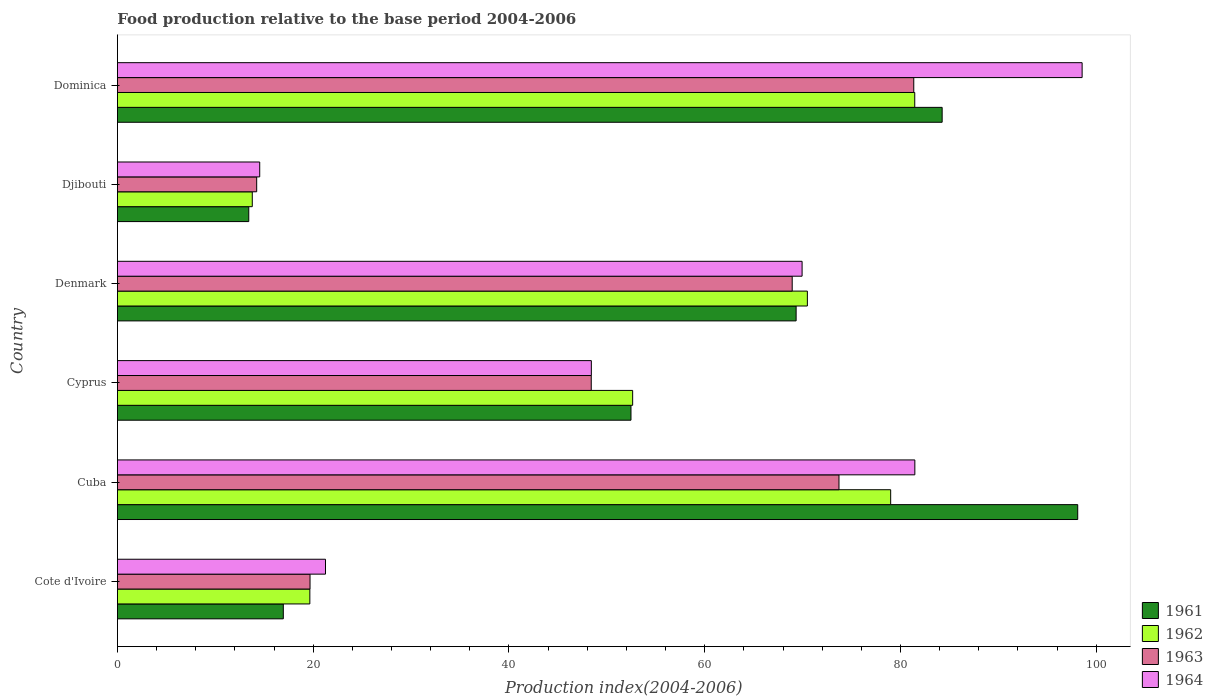Are the number of bars per tick equal to the number of legend labels?
Keep it short and to the point. Yes. How many bars are there on the 3rd tick from the top?
Offer a very short reply. 4. What is the label of the 5th group of bars from the top?
Offer a terse response. Cuba. What is the food production index in 1963 in Cote d'Ivoire?
Offer a terse response. 19.68. Across all countries, what is the maximum food production index in 1962?
Offer a terse response. 81.46. Across all countries, what is the minimum food production index in 1961?
Your answer should be very brief. 13.42. In which country was the food production index in 1961 maximum?
Provide a succinct answer. Cuba. In which country was the food production index in 1963 minimum?
Ensure brevity in your answer.  Djibouti. What is the total food production index in 1962 in the graph?
Keep it short and to the point. 317.03. What is the difference between the food production index in 1962 in Cote d'Ivoire and that in Cuba?
Make the answer very short. -59.34. What is the difference between the food production index in 1963 in Cote d'Ivoire and the food production index in 1964 in Djibouti?
Your answer should be compact. 5.14. What is the average food production index in 1964 per country?
Provide a succinct answer. 55.7. What is the difference between the food production index in 1961 and food production index in 1963 in Djibouti?
Give a very brief answer. -0.81. What is the ratio of the food production index in 1961 in Cote d'Ivoire to that in Cyprus?
Provide a short and direct response. 0.32. Is the food production index in 1964 in Cyprus less than that in Denmark?
Your answer should be very brief. Yes. What is the difference between the highest and the second highest food production index in 1963?
Provide a succinct answer. 7.64. What is the difference between the highest and the lowest food production index in 1962?
Make the answer very short. 67.68. Is it the case that in every country, the sum of the food production index in 1962 and food production index in 1961 is greater than the sum of food production index in 1964 and food production index in 1963?
Make the answer very short. No. What does the 4th bar from the bottom in Djibouti represents?
Provide a succinct answer. 1964. Is it the case that in every country, the sum of the food production index in 1962 and food production index in 1961 is greater than the food production index in 1963?
Provide a short and direct response. Yes. How many bars are there?
Ensure brevity in your answer.  24. What is the difference between two consecutive major ticks on the X-axis?
Provide a short and direct response. 20. Does the graph contain any zero values?
Ensure brevity in your answer.  No. Does the graph contain grids?
Offer a terse response. No. Where does the legend appear in the graph?
Make the answer very short. Bottom right. How many legend labels are there?
Your response must be concise. 4. How are the legend labels stacked?
Your answer should be compact. Vertical. What is the title of the graph?
Keep it short and to the point. Food production relative to the base period 2004-2006. Does "2006" appear as one of the legend labels in the graph?
Make the answer very short. No. What is the label or title of the X-axis?
Give a very brief answer. Production index(2004-2006). What is the Production index(2004-2006) of 1961 in Cote d'Ivoire?
Make the answer very short. 16.95. What is the Production index(2004-2006) of 1962 in Cote d'Ivoire?
Make the answer very short. 19.66. What is the Production index(2004-2006) in 1963 in Cote d'Ivoire?
Keep it short and to the point. 19.68. What is the Production index(2004-2006) in 1964 in Cote d'Ivoire?
Your answer should be very brief. 21.26. What is the Production index(2004-2006) in 1961 in Cuba?
Your answer should be compact. 98.11. What is the Production index(2004-2006) in 1962 in Cuba?
Your answer should be compact. 79. What is the Production index(2004-2006) of 1963 in Cuba?
Give a very brief answer. 73.72. What is the Production index(2004-2006) of 1964 in Cuba?
Your answer should be very brief. 81.47. What is the Production index(2004-2006) in 1961 in Cyprus?
Your answer should be compact. 52.47. What is the Production index(2004-2006) in 1962 in Cyprus?
Offer a very short reply. 52.64. What is the Production index(2004-2006) in 1963 in Cyprus?
Make the answer very short. 48.41. What is the Production index(2004-2006) in 1964 in Cyprus?
Give a very brief answer. 48.42. What is the Production index(2004-2006) in 1961 in Denmark?
Offer a very short reply. 69.34. What is the Production index(2004-2006) of 1962 in Denmark?
Provide a short and direct response. 70.49. What is the Production index(2004-2006) of 1963 in Denmark?
Offer a very short reply. 68.94. What is the Production index(2004-2006) in 1964 in Denmark?
Keep it short and to the point. 69.95. What is the Production index(2004-2006) of 1961 in Djibouti?
Ensure brevity in your answer.  13.42. What is the Production index(2004-2006) in 1962 in Djibouti?
Your answer should be compact. 13.78. What is the Production index(2004-2006) of 1963 in Djibouti?
Offer a terse response. 14.23. What is the Production index(2004-2006) of 1964 in Djibouti?
Make the answer very short. 14.54. What is the Production index(2004-2006) in 1961 in Dominica?
Provide a succinct answer. 84.26. What is the Production index(2004-2006) of 1962 in Dominica?
Ensure brevity in your answer.  81.46. What is the Production index(2004-2006) of 1963 in Dominica?
Provide a succinct answer. 81.36. What is the Production index(2004-2006) in 1964 in Dominica?
Your answer should be compact. 98.56. Across all countries, what is the maximum Production index(2004-2006) in 1961?
Make the answer very short. 98.11. Across all countries, what is the maximum Production index(2004-2006) of 1962?
Your response must be concise. 81.46. Across all countries, what is the maximum Production index(2004-2006) of 1963?
Provide a short and direct response. 81.36. Across all countries, what is the maximum Production index(2004-2006) of 1964?
Your answer should be compact. 98.56. Across all countries, what is the minimum Production index(2004-2006) of 1961?
Offer a terse response. 13.42. Across all countries, what is the minimum Production index(2004-2006) of 1962?
Your answer should be very brief. 13.78. Across all countries, what is the minimum Production index(2004-2006) in 1963?
Provide a short and direct response. 14.23. Across all countries, what is the minimum Production index(2004-2006) in 1964?
Offer a very short reply. 14.54. What is the total Production index(2004-2006) in 1961 in the graph?
Offer a very short reply. 334.55. What is the total Production index(2004-2006) of 1962 in the graph?
Give a very brief answer. 317.03. What is the total Production index(2004-2006) in 1963 in the graph?
Your response must be concise. 306.34. What is the total Production index(2004-2006) of 1964 in the graph?
Provide a succinct answer. 334.2. What is the difference between the Production index(2004-2006) in 1961 in Cote d'Ivoire and that in Cuba?
Provide a succinct answer. -81.16. What is the difference between the Production index(2004-2006) in 1962 in Cote d'Ivoire and that in Cuba?
Your answer should be compact. -59.34. What is the difference between the Production index(2004-2006) in 1963 in Cote d'Ivoire and that in Cuba?
Keep it short and to the point. -54.04. What is the difference between the Production index(2004-2006) in 1964 in Cote d'Ivoire and that in Cuba?
Offer a very short reply. -60.21. What is the difference between the Production index(2004-2006) of 1961 in Cote d'Ivoire and that in Cyprus?
Provide a short and direct response. -35.52. What is the difference between the Production index(2004-2006) of 1962 in Cote d'Ivoire and that in Cyprus?
Keep it short and to the point. -32.98. What is the difference between the Production index(2004-2006) in 1963 in Cote d'Ivoire and that in Cyprus?
Keep it short and to the point. -28.73. What is the difference between the Production index(2004-2006) of 1964 in Cote d'Ivoire and that in Cyprus?
Keep it short and to the point. -27.16. What is the difference between the Production index(2004-2006) of 1961 in Cote d'Ivoire and that in Denmark?
Provide a succinct answer. -52.39. What is the difference between the Production index(2004-2006) of 1962 in Cote d'Ivoire and that in Denmark?
Ensure brevity in your answer.  -50.83. What is the difference between the Production index(2004-2006) in 1963 in Cote d'Ivoire and that in Denmark?
Provide a short and direct response. -49.26. What is the difference between the Production index(2004-2006) in 1964 in Cote d'Ivoire and that in Denmark?
Your response must be concise. -48.69. What is the difference between the Production index(2004-2006) in 1961 in Cote d'Ivoire and that in Djibouti?
Offer a terse response. 3.53. What is the difference between the Production index(2004-2006) of 1962 in Cote d'Ivoire and that in Djibouti?
Keep it short and to the point. 5.88. What is the difference between the Production index(2004-2006) of 1963 in Cote d'Ivoire and that in Djibouti?
Offer a very short reply. 5.45. What is the difference between the Production index(2004-2006) in 1964 in Cote d'Ivoire and that in Djibouti?
Your answer should be compact. 6.72. What is the difference between the Production index(2004-2006) of 1961 in Cote d'Ivoire and that in Dominica?
Keep it short and to the point. -67.31. What is the difference between the Production index(2004-2006) in 1962 in Cote d'Ivoire and that in Dominica?
Offer a very short reply. -61.8. What is the difference between the Production index(2004-2006) in 1963 in Cote d'Ivoire and that in Dominica?
Your answer should be compact. -61.68. What is the difference between the Production index(2004-2006) of 1964 in Cote d'Ivoire and that in Dominica?
Give a very brief answer. -77.3. What is the difference between the Production index(2004-2006) in 1961 in Cuba and that in Cyprus?
Offer a very short reply. 45.64. What is the difference between the Production index(2004-2006) of 1962 in Cuba and that in Cyprus?
Your answer should be very brief. 26.36. What is the difference between the Production index(2004-2006) of 1963 in Cuba and that in Cyprus?
Your response must be concise. 25.31. What is the difference between the Production index(2004-2006) of 1964 in Cuba and that in Cyprus?
Give a very brief answer. 33.05. What is the difference between the Production index(2004-2006) of 1961 in Cuba and that in Denmark?
Your answer should be compact. 28.77. What is the difference between the Production index(2004-2006) of 1962 in Cuba and that in Denmark?
Provide a succinct answer. 8.51. What is the difference between the Production index(2004-2006) of 1963 in Cuba and that in Denmark?
Give a very brief answer. 4.78. What is the difference between the Production index(2004-2006) in 1964 in Cuba and that in Denmark?
Keep it short and to the point. 11.52. What is the difference between the Production index(2004-2006) of 1961 in Cuba and that in Djibouti?
Provide a succinct answer. 84.69. What is the difference between the Production index(2004-2006) in 1962 in Cuba and that in Djibouti?
Ensure brevity in your answer.  65.22. What is the difference between the Production index(2004-2006) of 1963 in Cuba and that in Djibouti?
Offer a terse response. 59.49. What is the difference between the Production index(2004-2006) of 1964 in Cuba and that in Djibouti?
Keep it short and to the point. 66.93. What is the difference between the Production index(2004-2006) of 1961 in Cuba and that in Dominica?
Keep it short and to the point. 13.85. What is the difference between the Production index(2004-2006) of 1962 in Cuba and that in Dominica?
Ensure brevity in your answer.  -2.46. What is the difference between the Production index(2004-2006) of 1963 in Cuba and that in Dominica?
Provide a succinct answer. -7.64. What is the difference between the Production index(2004-2006) in 1964 in Cuba and that in Dominica?
Offer a very short reply. -17.09. What is the difference between the Production index(2004-2006) in 1961 in Cyprus and that in Denmark?
Offer a very short reply. -16.87. What is the difference between the Production index(2004-2006) in 1962 in Cyprus and that in Denmark?
Provide a succinct answer. -17.85. What is the difference between the Production index(2004-2006) in 1963 in Cyprus and that in Denmark?
Give a very brief answer. -20.53. What is the difference between the Production index(2004-2006) of 1964 in Cyprus and that in Denmark?
Your answer should be compact. -21.53. What is the difference between the Production index(2004-2006) in 1961 in Cyprus and that in Djibouti?
Give a very brief answer. 39.05. What is the difference between the Production index(2004-2006) in 1962 in Cyprus and that in Djibouti?
Provide a succinct answer. 38.86. What is the difference between the Production index(2004-2006) in 1963 in Cyprus and that in Djibouti?
Make the answer very short. 34.18. What is the difference between the Production index(2004-2006) of 1964 in Cyprus and that in Djibouti?
Your answer should be compact. 33.88. What is the difference between the Production index(2004-2006) of 1961 in Cyprus and that in Dominica?
Your response must be concise. -31.79. What is the difference between the Production index(2004-2006) of 1962 in Cyprus and that in Dominica?
Provide a succinct answer. -28.82. What is the difference between the Production index(2004-2006) of 1963 in Cyprus and that in Dominica?
Your answer should be very brief. -32.95. What is the difference between the Production index(2004-2006) in 1964 in Cyprus and that in Dominica?
Make the answer very short. -50.14. What is the difference between the Production index(2004-2006) in 1961 in Denmark and that in Djibouti?
Offer a terse response. 55.92. What is the difference between the Production index(2004-2006) in 1962 in Denmark and that in Djibouti?
Your response must be concise. 56.71. What is the difference between the Production index(2004-2006) in 1963 in Denmark and that in Djibouti?
Keep it short and to the point. 54.71. What is the difference between the Production index(2004-2006) of 1964 in Denmark and that in Djibouti?
Offer a very short reply. 55.41. What is the difference between the Production index(2004-2006) in 1961 in Denmark and that in Dominica?
Offer a terse response. -14.92. What is the difference between the Production index(2004-2006) in 1962 in Denmark and that in Dominica?
Provide a short and direct response. -10.97. What is the difference between the Production index(2004-2006) in 1963 in Denmark and that in Dominica?
Offer a terse response. -12.42. What is the difference between the Production index(2004-2006) in 1964 in Denmark and that in Dominica?
Your answer should be compact. -28.61. What is the difference between the Production index(2004-2006) of 1961 in Djibouti and that in Dominica?
Make the answer very short. -70.84. What is the difference between the Production index(2004-2006) in 1962 in Djibouti and that in Dominica?
Offer a very short reply. -67.68. What is the difference between the Production index(2004-2006) of 1963 in Djibouti and that in Dominica?
Provide a succinct answer. -67.13. What is the difference between the Production index(2004-2006) of 1964 in Djibouti and that in Dominica?
Offer a very short reply. -84.02. What is the difference between the Production index(2004-2006) in 1961 in Cote d'Ivoire and the Production index(2004-2006) in 1962 in Cuba?
Your response must be concise. -62.05. What is the difference between the Production index(2004-2006) in 1961 in Cote d'Ivoire and the Production index(2004-2006) in 1963 in Cuba?
Keep it short and to the point. -56.77. What is the difference between the Production index(2004-2006) of 1961 in Cote d'Ivoire and the Production index(2004-2006) of 1964 in Cuba?
Your response must be concise. -64.52. What is the difference between the Production index(2004-2006) of 1962 in Cote d'Ivoire and the Production index(2004-2006) of 1963 in Cuba?
Make the answer very short. -54.06. What is the difference between the Production index(2004-2006) of 1962 in Cote d'Ivoire and the Production index(2004-2006) of 1964 in Cuba?
Ensure brevity in your answer.  -61.81. What is the difference between the Production index(2004-2006) of 1963 in Cote d'Ivoire and the Production index(2004-2006) of 1964 in Cuba?
Offer a terse response. -61.79. What is the difference between the Production index(2004-2006) of 1961 in Cote d'Ivoire and the Production index(2004-2006) of 1962 in Cyprus?
Your answer should be very brief. -35.69. What is the difference between the Production index(2004-2006) of 1961 in Cote d'Ivoire and the Production index(2004-2006) of 1963 in Cyprus?
Offer a very short reply. -31.46. What is the difference between the Production index(2004-2006) in 1961 in Cote d'Ivoire and the Production index(2004-2006) in 1964 in Cyprus?
Give a very brief answer. -31.47. What is the difference between the Production index(2004-2006) in 1962 in Cote d'Ivoire and the Production index(2004-2006) in 1963 in Cyprus?
Provide a succinct answer. -28.75. What is the difference between the Production index(2004-2006) in 1962 in Cote d'Ivoire and the Production index(2004-2006) in 1964 in Cyprus?
Keep it short and to the point. -28.76. What is the difference between the Production index(2004-2006) of 1963 in Cote d'Ivoire and the Production index(2004-2006) of 1964 in Cyprus?
Offer a terse response. -28.74. What is the difference between the Production index(2004-2006) of 1961 in Cote d'Ivoire and the Production index(2004-2006) of 1962 in Denmark?
Provide a short and direct response. -53.54. What is the difference between the Production index(2004-2006) in 1961 in Cote d'Ivoire and the Production index(2004-2006) in 1963 in Denmark?
Your answer should be very brief. -51.99. What is the difference between the Production index(2004-2006) of 1961 in Cote d'Ivoire and the Production index(2004-2006) of 1964 in Denmark?
Your response must be concise. -53. What is the difference between the Production index(2004-2006) in 1962 in Cote d'Ivoire and the Production index(2004-2006) in 1963 in Denmark?
Offer a very short reply. -49.28. What is the difference between the Production index(2004-2006) in 1962 in Cote d'Ivoire and the Production index(2004-2006) in 1964 in Denmark?
Your answer should be very brief. -50.29. What is the difference between the Production index(2004-2006) of 1963 in Cote d'Ivoire and the Production index(2004-2006) of 1964 in Denmark?
Keep it short and to the point. -50.27. What is the difference between the Production index(2004-2006) of 1961 in Cote d'Ivoire and the Production index(2004-2006) of 1962 in Djibouti?
Make the answer very short. 3.17. What is the difference between the Production index(2004-2006) in 1961 in Cote d'Ivoire and the Production index(2004-2006) in 1963 in Djibouti?
Your response must be concise. 2.72. What is the difference between the Production index(2004-2006) in 1961 in Cote d'Ivoire and the Production index(2004-2006) in 1964 in Djibouti?
Your answer should be very brief. 2.41. What is the difference between the Production index(2004-2006) of 1962 in Cote d'Ivoire and the Production index(2004-2006) of 1963 in Djibouti?
Your answer should be compact. 5.43. What is the difference between the Production index(2004-2006) in 1962 in Cote d'Ivoire and the Production index(2004-2006) in 1964 in Djibouti?
Your answer should be very brief. 5.12. What is the difference between the Production index(2004-2006) of 1963 in Cote d'Ivoire and the Production index(2004-2006) of 1964 in Djibouti?
Offer a very short reply. 5.14. What is the difference between the Production index(2004-2006) in 1961 in Cote d'Ivoire and the Production index(2004-2006) in 1962 in Dominica?
Give a very brief answer. -64.51. What is the difference between the Production index(2004-2006) in 1961 in Cote d'Ivoire and the Production index(2004-2006) in 1963 in Dominica?
Provide a short and direct response. -64.41. What is the difference between the Production index(2004-2006) in 1961 in Cote d'Ivoire and the Production index(2004-2006) in 1964 in Dominica?
Offer a very short reply. -81.61. What is the difference between the Production index(2004-2006) of 1962 in Cote d'Ivoire and the Production index(2004-2006) of 1963 in Dominica?
Your answer should be very brief. -61.7. What is the difference between the Production index(2004-2006) of 1962 in Cote d'Ivoire and the Production index(2004-2006) of 1964 in Dominica?
Offer a terse response. -78.9. What is the difference between the Production index(2004-2006) in 1963 in Cote d'Ivoire and the Production index(2004-2006) in 1964 in Dominica?
Provide a short and direct response. -78.88. What is the difference between the Production index(2004-2006) in 1961 in Cuba and the Production index(2004-2006) in 1962 in Cyprus?
Offer a terse response. 45.47. What is the difference between the Production index(2004-2006) in 1961 in Cuba and the Production index(2004-2006) in 1963 in Cyprus?
Offer a very short reply. 49.7. What is the difference between the Production index(2004-2006) of 1961 in Cuba and the Production index(2004-2006) of 1964 in Cyprus?
Provide a succinct answer. 49.69. What is the difference between the Production index(2004-2006) of 1962 in Cuba and the Production index(2004-2006) of 1963 in Cyprus?
Offer a very short reply. 30.59. What is the difference between the Production index(2004-2006) of 1962 in Cuba and the Production index(2004-2006) of 1964 in Cyprus?
Give a very brief answer. 30.58. What is the difference between the Production index(2004-2006) in 1963 in Cuba and the Production index(2004-2006) in 1964 in Cyprus?
Provide a succinct answer. 25.3. What is the difference between the Production index(2004-2006) in 1961 in Cuba and the Production index(2004-2006) in 1962 in Denmark?
Make the answer very short. 27.62. What is the difference between the Production index(2004-2006) in 1961 in Cuba and the Production index(2004-2006) in 1963 in Denmark?
Offer a terse response. 29.17. What is the difference between the Production index(2004-2006) in 1961 in Cuba and the Production index(2004-2006) in 1964 in Denmark?
Keep it short and to the point. 28.16. What is the difference between the Production index(2004-2006) of 1962 in Cuba and the Production index(2004-2006) of 1963 in Denmark?
Provide a succinct answer. 10.06. What is the difference between the Production index(2004-2006) in 1962 in Cuba and the Production index(2004-2006) in 1964 in Denmark?
Provide a succinct answer. 9.05. What is the difference between the Production index(2004-2006) of 1963 in Cuba and the Production index(2004-2006) of 1964 in Denmark?
Your response must be concise. 3.77. What is the difference between the Production index(2004-2006) of 1961 in Cuba and the Production index(2004-2006) of 1962 in Djibouti?
Give a very brief answer. 84.33. What is the difference between the Production index(2004-2006) in 1961 in Cuba and the Production index(2004-2006) in 1963 in Djibouti?
Keep it short and to the point. 83.88. What is the difference between the Production index(2004-2006) of 1961 in Cuba and the Production index(2004-2006) of 1964 in Djibouti?
Offer a terse response. 83.57. What is the difference between the Production index(2004-2006) of 1962 in Cuba and the Production index(2004-2006) of 1963 in Djibouti?
Your response must be concise. 64.77. What is the difference between the Production index(2004-2006) of 1962 in Cuba and the Production index(2004-2006) of 1964 in Djibouti?
Your response must be concise. 64.46. What is the difference between the Production index(2004-2006) of 1963 in Cuba and the Production index(2004-2006) of 1964 in Djibouti?
Your response must be concise. 59.18. What is the difference between the Production index(2004-2006) in 1961 in Cuba and the Production index(2004-2006) in 1962 in Dominica?
Your answer should be compact. 16.65. What is the difference between the Production index(2004-2006) in 1961 in Cuba and the Production index(2004-2006) in 1963 in Dominica?
Your answer should be compact. 16.75. What is the difference between the Production index(2004-2006) in 1961 in Cuba and the Production index(2004-2006) in 1964 in Dominica?
Give a very brief answer. -0.45. What is the difference between the Production index(2004-2006) of 1962 in Cuba and the Production index(2004-2006) of 1963 in Dominica?
Provide a succinct answer. -2.36. What is the difference between the Production index(2004-2006) in 1962 in Cuba and the Production index(2004-2006) in 1964 in Dominica?
Give a very brief answer. -19.56. What is the difference between the Production index(2004-2006) in 1963 in Cuba and the Production index(2004-2006) in 1964 in Dominica?
Offer a terse response. -24.84. What is the difference between the Production index(2004-2006) in 1961 in Cyprus and the Production index(2004-2006) in 1962 in Denmark?
Offer a terse response. -18.02. What is the difference between the Production index(2004-2006) in 1961 in Cyprus and the Production index(2004-2006) in 1963 in Denmark?
Ensure brevity in your answer.  -16.47. What is the difference between the Production index(2004-2006) in 1961 in Cyprus and the Production index(2004-2006) in 1964 in Denmark?
Make the answer very short. -17.48. What is the difference between the Production index(2004-2006) of 1962 in Cyprus and the Production index(2004-2006) of 1963 in Denmark?
Offer a very short reply. -16.3. What is the difference between the Production index(2004-2006) in 1962 in Cyprus and the Production index(2004-2006) in 1964 in Denmark?
Your answer should be compact. -17.31. What is the difference between the Production index(2004-2006) in 1963 in Cyprus and the Production index(2004-2006) in 1964 in Denmark?
Provide a short and direct response. -21.54. What is the difference between the Production index(2004-2006) in 1961 in Cyprus and the Production index(2004-2006) in 1962 in Djibouti?
Provide a short and direct response. 38.69. What is the difference between the Production index(2004-2006) of 1961 in Cyprus and the Production index(2004-2006) of 1963 in Djibouti?
Provide a succinct answer. 38.24. What is the difference between the Production index(2004-2006) of 1961 in Cyprus and the Production index(2004-2006) of 1964 in Djibouti?
Give a very brief answer. 37.93. What is the difference between the Production index(2004-2006) of 1962 in Cyprus and the Production index(2004-2006) of 1963 in Djibouti?
Make the answer very short. 38.41. What is the difference between the Production index(2004-2006) in 1962 in Cyprus and the Production index(2004-2006) in 1964 in Djibouti?
Your answer should be very brief. 38.1. What is the difference between the Production index(2004-2006) of 1963 in Cyprus and the Production index(2004-2006) of 1964 in Djibouti?
Your answer should be very brief. 33.87. What is the difference between the Production index(2004-2006) of 1961 in Cyprus and the Production index(2004-2006) of 1962 in Dominica?
Offer a very short reply. -28.99. What is the difference between the Production index(2004-2006) in 1961 in Cyprus and the Production index(2004-2006) in 1963 in Dominica?
Make the answer very short. -28.89. What is the difference between the Production index(2004-2006) in 1961 in Cyprus and the Production index(2004-2006) in 1964 in Dominica?
Your response must be concise. -46.09. What is the difference between the Production index(2004-2006) in 1962 in Cyprus and the Production index(2004-2006) in 1963 in Dominica?
Provide a succinct answer. -28.72. What is the difference between the Production index(2004-2006) in 1962 in Cyprus and the Production index(2004-2006) in 1964 in Dominica?
Offer a terse response. -45.92. What is the difference between the Production index(2004-2006) of 1963 in Cyprus and the Production index(2004-2006) of 1964 in Dominica?
Provide a succinct answer. -50.15. What is the difference between the Production index(2004-2006) in 1961 in Denmark and the Production index(2004-2006) in 1962 in Djibouti?
Provide a short and direct response. 55.56. What is the difference between the Production index(2004-2006) in 1961 in Denmark and the Production index(2004-2006) in 1963 in Djibouti?
Offer a terse response. 55.11. What is the difference between the Production index(2004-2006) of 1961 in Denmark and the Production index(2004-2006) of 1964 in Djibouti?
Offer a very short reply. 54.8. What is the difference between the Production index(2004-2006) in 1962 in Denmark and the Production index(2004-2006) in 1963 in Djibouti?
Keep it short and to the point. 56.26. What is the difference between the Production index(2004-2006) in 1962 in Denmark and the Production index(2004-2006) in 1964 in Djibouti?
Ensure brevity in your answer.  55.95. What is the difference between the Production index(2004-2006) of 1963 in Denmark and the Production index(2004-2006) of 1964 in Djibouti?
Provide a short and direct response. 54.4. What is the difference between the Production index(2004-2006) in 1961 in Denmark and the Production index(2004-2006) in 1962 in Dominica?
Provide a short and direct response. -12.12. What is the difference between the Production index(2004-2006) of 1961 in Denmark and the Production index(2004-2006) of 1963 in Dominica?
Provide a succinct answer. -12.02. What is the difference between the Production index(2004-2006) in 1961 in Denmark and the Production index(2004-2006) in 1964 in Dominica?
Ensure brevity in your answer.  -29.22. What is the difference between the Production index(2004-2006) in 1962 in Denmark and the Production index(2004-2006) in 1963 in Dominica?
Your answer should be compact. -10.87. What is the difference between the Production index(2004-2006) of 1962 in Denmark and the Production index(2004-2006) of 1964 in Dominica?
Give a very brief answer. -28.07. What is the difference between the Production index(2004-2006) of 1963 in Denmark and the Production index(2004-2006) of 1964 in Dominica?
Your response must be concise. -29.62. What is the difference between the Production index(2004-2006) of 1961 in Djibouti and the Production index(2004-2006) of 1962 in Dominica?
Offer a very short reply. -68.04. What is the difference between the Production index(2004-2006) of 1961 in Djibouti and the Production index(2004-2006) of 1963 in Dominica?
Offer a terse response. -67.94. What is the difference between the Production index(2004-2006) of 1961 in Djibouti and the Production index(2004-2006) of 1964 in Dominica?
Your response must be concise. -85.14. What is the difference between the Production index(2004-2006) of 1962 in Djibouti and the Production index(2004-2006) of 1963 in Dominica?
Provide a succinct answer. -67.58. What is the difference between the Production index(2004-2006) of 1962 in Djibouti and the Production index(2004-2006) of 1964 in Dominica?
Your answer should be compact. -84.78. What is the difference between the Production index(2004-2006) of 1963 in Djibouti and the Production index(2004-2006) of 1964 in Dominica?
Your answer should be compact. -84.33. What is the average Production index(2004-2006) in 1961 per country?
Your response must be concise. 55.76. What is the average Production index(2004-2006) of 1962 per country?
Make the answer very short. 52.84. What is the average Production index(2004-2006) of 1963 per country?
Offer a terse response. 51.06. What is the average Production index(2004-2006) of 1964 per country?
Your answer should be very brief. 55.7. What is the difference between the Production index(2004-2006) of 1961 and Production index(2004-2006) of 1962 in Cote d'Ivoire?
Keep it short and to the point. -2.71. What is the difference between the Production index(2004-2006) of 1961 and Production index(2004-2006) of 1963 in Cote d'Ivoire?
Your answer should be compact. -2.73. What is the difference between the Production index(2004-2006) of 1961 and Production index(2004-2006) of 1964 in Cote d'Ivoire?
Offer a very short reply. -4.31. What is the difference between the Production index(2004-2006) in 1962 and Production index(2004-2006) in 1963 in Cote d'Ivoire?
Your answer should be very brief. -0.02. What is the difference between the Production index(2004-2006) in 1962 and Production index(2004-2006) in 1964 in Cote d'Ivoire?
Ensure brevity in your answer.  -1.6. What is the difference between the Production index(2004-2006) of 1963 and Production index(2004-2006) of 1964 in Cote d'Ivoire?
Ensure brevity in your answer.  -1.58. What is the difference between the Production index(2004-2006) in 1961 and Production index(2004-2006) in 1962 in Cuba?
Ensure brevity in your answer.  19.11. What is the difference between the Production index(2004-2006) of 1961 and Production index(2004-2006) of 1963 in Cuba?
Your answer should be compact. 24.39. What is the difference between the Production index(2004-2006) of 1961 and Production index(2004-2006) of 1964 in Cuba?
Provide a short and direct response. 16.64. What is the difference between the Production index(2004-2006) in 1962 and Production index(2004-2006) in 1963 in Cuba?
Offer a very short reply. 5.28. What is the difference between the Production index(2004-2006) in 1962 and Production index(2004-2006) in 1964 in Cuba?
Your response must be concise. -2.47. What is the difference between the Production index(2004-2006) in 1963 and Production index(2004-2006) in 1964 in Cuba?
Your answer should be compact. -7.75. What is the difference between the Production index(2004-2006) of 1961 and Production index(2004-2006) of 1962 in Cyprus?
Keep it short and to the point. -0.17. What is the difference between the Production index(2004-2006) of 1961 and Production index(2004-2006) of 1963 in Cyprus?
Give a very brief answer. 4.06. What is the difference between the Production index(2004-2006) of 1961 and Production index(2004-2006) of 1964 in Cyprus?
Offer a very short reply. 4.05. What is the difference between the Production index(2004-2006) of 1962 and Production index(2004-2006) of 1963 in Cyprus?
Make the answer very short. 4.23. What is the difference between the Production index(2004-2006) of 1962 and Production index(2004-2006) of 1964 in Cyprus?
Offer a very short reply. 4.22. What is the difference between the Production index(2004-2006) of 1963 and Production index(2004-2006) of 1964 in Cyprus?
Provide a succinct answer. -0.01. What is the difference between the Production index(2004-2006) in 1961 and Production index(2004-2006) in 1962 in Denmark?
Your response must be concise. -1.15. What is the difference between the Production index(2004-2006) in 1961 and Production index(2004-2006) in 1963 in Denmark?
Ensure brevity in your answer.  0.4. What is the difference between the Production index(2004-2006) of 1961 and Production index(2004-2006) of 1964 in Denmark?
Ensure brevity in your answer.  -0.61. What is the difference between the Production index(2004-2006) of 1962 and Production index(2004-2006) of 1963 in Denmark?
Keep it short and to the point. 1.55. What is the difference between the Production index(2004-2006) of 1962 and Production index(2004-2006) of 1964 in Denmark?
Offer a very short reply. 0.54. What is the difference between the Production index(2004-2006) in 1963 and Production index(2004-2006) in 1964 in Denmark?
Offer a very short reply. -1.01. What is the difference between the Production index(2004-2006) in 1961 and Production index(2004-2006) in 1962 in Djibouti?
Make the answer very short. -0.36. What is the difference between the Production index(2004-2006) in 1961 and Production index(2004-2006) in 1963 in Djibouti?
Offer a terse response. -0.81. What is the difference between the Production index(2004-2006) in 1961 and Production index(2004-2006) in 1964 in Djibouti?
Make the answer very short. -1.12. What is the difference between the Production index(2004-2006) of 1962 and Production index(2004-2006) of 1963 in Djibouti?
Your answer should be compact. -0.45. What is the difference between the Production index(2004-2006) of 1962 and Production index(2004-2006) of 1964 in Djibouti?
Make the answer very short. -0.76. What is the difference between the Production index(2004-2006) of 1963 and Production index(2004-2006) of 1964 in Djibouti?
Provide a short and direct response. -0.31. What is the difference between the Production index(2004-2006) of 1961 and Production index(2004-2006) of 1964 in Dominica?
Offer a terse response. -14.3. What is the difference between the Production index(2004-2006) in 1962 and Production index(2004-2006) in 1963 in Dominica?
Provide a succinct answer. 0.1. What is the difference between the Production index(2004-2006) in 1962 and Production index(2004-2006) in 1964 in Dominica?
Provide a succinct answer. -17.1. What is the difference between the Production index(2004-2006) of 1963 and Production index(2004-2006) of 1964 in Dominica?
Your answer should be compact. -17.2. What is the ratio of the Production index(2004-2006) of 1961 in Cote d'Ivoire to that in Cuba?
Provide a short and direct response. 0.17. What is the ratio of the Production index(2004-2006) of 1962 in Cote d'Ivoire to that in Cuba?
Give a very brief answer. 0.25. What is the ratio of the Production index(2004-2006) in 1963 in Cote d'Ivoire to that in Cuba?
Your response must be concise. 0.27. What is the ratio of the Production index(2004-2006) in 1964 in Cote d'Ivoire to that in Cuba?
Offer a terse response. 0.26. What is the ratio of the Production index(2004-2006) in 1961 in Cote d'Ivoire to that in Cyprus?
Offer a very short reply. 0.32. What is the ratio of the Production index(2004-2006) of 1962 in Cote d'Ivoire to that in Cyprus?
Your answer should be very brief. 0.37. What is the ratio of the Production index(2004-2006) of 1963 in Cote d'Ivoire to that in Cyprus?
Keep it short and to the point. 0.41. What is the ratio of the Production index(2004-2006) of 1964 in Cote d'Ivoire to that in Cyprus?
Provide a succinct answer. 0.44. What is the ratio of the Production index(2004-2006) of 1961 in Cote d'Ivoire to that in Denmark?
Offer a terse response. 0.24. What is the ratio of the Production index(2004-2006) in 1962 in Cote d'Ivoire to that in Denmark?
Offer a terse response. 0.28. What is the ratio of the Production index(2004-2006) of 1963 in Cote d'Ivoire to that in Denmark?
Keep it short and to the point. 0.29. What is the ratio of the Production index(2004-2006) in 1964 in Cote d'Ivoire to that in Denmark?
Offer a very short reply. 0.3. What is the ratio of the Production index(2004-2006) of 1961 in Cote d'Ivoire to that in Djibouti?
Provide a succinct answer. 1.26. What is the ratio of the Production index(2004-2006) of 1962 in Cote d'Ivoire to that in Djibouti?
Your answer should be compact. 1.43. What is the ratio of the Production index(2004-2006) in 1963 in Cote d'Ivoire to that in Djibouti?
Your answer should be very brief. 1.38. What is the ratio of the Production index(2004-2006) of 1964 in Cote d'Ivoire to that in Djibouti?
Your answer should be compact. 1.46. What is the ratio of the Production index(2004-2006) in 1961 in Cote d'Ivoire to that in Dominica?
Your answer should be very brief. 0.2. What is the ratio of the Production index(2004-2006) in 1962 in Cote d'Ivoire to that in Dominica?
Offer a terse response. 0.24. What is the ratio of the Production index(2004-2006) of 1963 in Cote d'Ivoire to that in Dominica?
Keep it short and to the point. 0.24. What is the ratio of the Production index(2004-2006) of 1964 in Cote d'Ivoire to that in Dominica?
Provide a short and direct response. 0.22. What is the ratio of the Production index(2004-2006) of 1961 in Cuba to that in Cyprus?
Your answer should be compact. 1.87. What is the ratio of the Production index(2004-2006) in 1962 in Cuba to that in Cyprus?
Make the answer very short. 1.5. What is the ratio of the Production index(2004-2006) of 1963 in Cuba to that in Cyprus?
Provide a short and direct response. 1.52. What is the ratio of the Production index(2004-2006) in 1964 in Cuba to that in Cyprus?
Your response must be concise. 1.68. What is the ratio of the Production index(2004-2006) in 1961 in Cuba to that in Denmark?
Provide a succinct answer. 1.41. What is the ratio of the Production index(2004-2006) in 1962 in Cuba to that in Denmark?
Provide a short and direct response. 1.12. What is the ratio of the Production index(2004-2006) in 1963 in Cuba to that in Denmark?
Make the answer very short. 1.07. What is the ratio of the Production index(2004-2006) of 1964 in Cuba to that in Denmark?
Your answer should be compact. 1.16. What is the ratio of the Production index(2004-2006) of 1961 in Cuba to that in Djibouti?
Your response must be concise. 7.31. What is the ratio of the Production index(2004-2006) in 1962 in Cuba to that in Djibouti?
Provide a succinct answer. 5.73. What is the ratio of the Production index(2004-2006) in 1963 in Cuba to that in Djibouti?
Offer a very short reply. 5.18. What is the ratio of the Production index(2004-2006) of 1964 in Cuba to that in Djibouti?
Provide a succinct answer. 5.6. What is the ratio of the Production index(2004-2006) in 1961 in Cuba to that in Dominica?
Keep it short and to the point. 1.16. What is the ratio of the Production index(2004-2006) of 1962 in Cuba to that in Dominica?
Keep it short and to the point. 0.97. What is the ratio of the Production index(2004-2006) in 1963 in Cuba to that in Dominica?
Offer a terse response. 0.91. What is the ratio of the Production index(2004-2006) in 1964 in Cuba to that in Dominica?
Your answer should be very brief. 0.83. What is the ratio of the Production index(2004-2006) of 1961 in Cyprus to that in Denmark?
Ensure brevity in your answer.  0.76. What is the ratio of the Production index(2004-2006) of 1962 in Cyprus to that in Denmark?
Your response must be concise. 0.75. What is the ratio of the Production index(2004-2006) of 1963 in Cyprus to that in Denmark?
Offer a terse response. 0.7. What is the ratio of the Production index(2004-2006) of 1964 in Cyprus to that in Denmark?
Your response must be concise. 0.69. What is the ratio of the Production index(2004-2006) in 1961 in Cyprus to that in Djibouti?
Your answer should be compact. 3.91. What is the ratio of the Production index(2004-2006) of 1962 in Cyprus to that in Djibouti?
Provide a succinct answer. 3.82. What is the ratio of the Production index(2004-2006) of 1963 in Cyprus to that in Djibouti?
Provide a succinct answer. 3.4. What is the ratio of the Production index(2004-2006) of 1964 in Cyprus to that in Djibouti?
Provide a short and direct response. 3.33. What is the ratio of the Production index(2004-2006) of 1961 in Cyprus to that in Dominica?
Give a very brief answer. 0.62. What is the ratio of the Production index(2004-2006) of 1962 in Cyprus to that in Dominica?
Ensure brevity in your answer.  0.65. What is the ratio of the Production index(2004-2006) in 1963 in Cyprus to that in Dominica?
Provide a succinct answer. 0.59. What is the ratio of the Production index(2004-2006) in 1964 in Cyprus to that in Dominica?
Provide a short and direct response. 0.49. What is the ratio of the Production index(2004-2006) in 1961 in Denmark to that in Djibouti?
Provide a short and direct response. 5.17. What is the ratio of the Production index(2004-2006) of 1962 in Denmark to that in Djibouti?
Your response must be concise. 5.12. What is the ratio of the Production index(2004-2006) in 1963 in Denmark to that in Djibouti?
Give a very brief answer. 4.84. What is the ratio of the Production index(2004-2006) in 1964 in Denmark to that in Djibouti?
Your answer should be very brief. 4.81. What is the ratio of the Production index(2004-2006) of 1961 in Denmark to that in Dominica?
Make the answer very short. 0.82. What is the ratio of the Production index(2004-2006) of 1962 in Denmark to that in Dominica?
Make the answer very short. 0.87. What is the ratio of the Production index(2004-2006) in 1963 in Denmark to that in Dominica?
Give a very brief answer. 0.85. What is the ratio of the Production index(2004-2006) of 1964 in Denmark to that in Dominica?
Keep it short and to the point. 0.71. What is the ratio of the Production index(2004-2006) in 1961 in Djibouti to that in Dominica?
Give a very brief answer. 0.16. What is the ratio of the Production index(2004-2006) of 1962 in Djibouti to that in Dominica?
Make the answer very short. 0.17. What is the ratio of the Production index(2004-2006) of 1963 in Djibouti to that in Dominica?
Provide a succinct answer. 0.17. What is the ratio of the Production index(2004-2006) of 1964 in Djibouti to that in Dominica?
Ensure brevity in your answer.  0.15. What is the difference between the highest and the second highest Production index(2004-2006) in 1961?
Your response must be concise. 13.85. What is the difference between the highest and the second highest Production index(2004-2006) in 1962?
Offer a terse response. 2.46. What is the difference between the highest and the second highest Production index(2004-2006) in 1963?
Give a very brief answer. 7.64. What is the difference between the highest and the second highest Production index(2004-2006) in 1964?
Offer a very short reply. 17.09. What is the difference between the highest and the lowest Production index(2004-2006) in 1961?
Your answer should be very brief. 84.69. What is the difference between the highest and the lowest Production index(2004-2006) of 1962?
Keep it short and to the point. 67.68. What is the difference between the highest and the lowest Production index(2004-2006) of 1963?
Make the answer very short. 67.13. What is the difference between the highest and the lowest Production index(2004-2006) in 1964?
Your answer should be very brief. 84.02. 